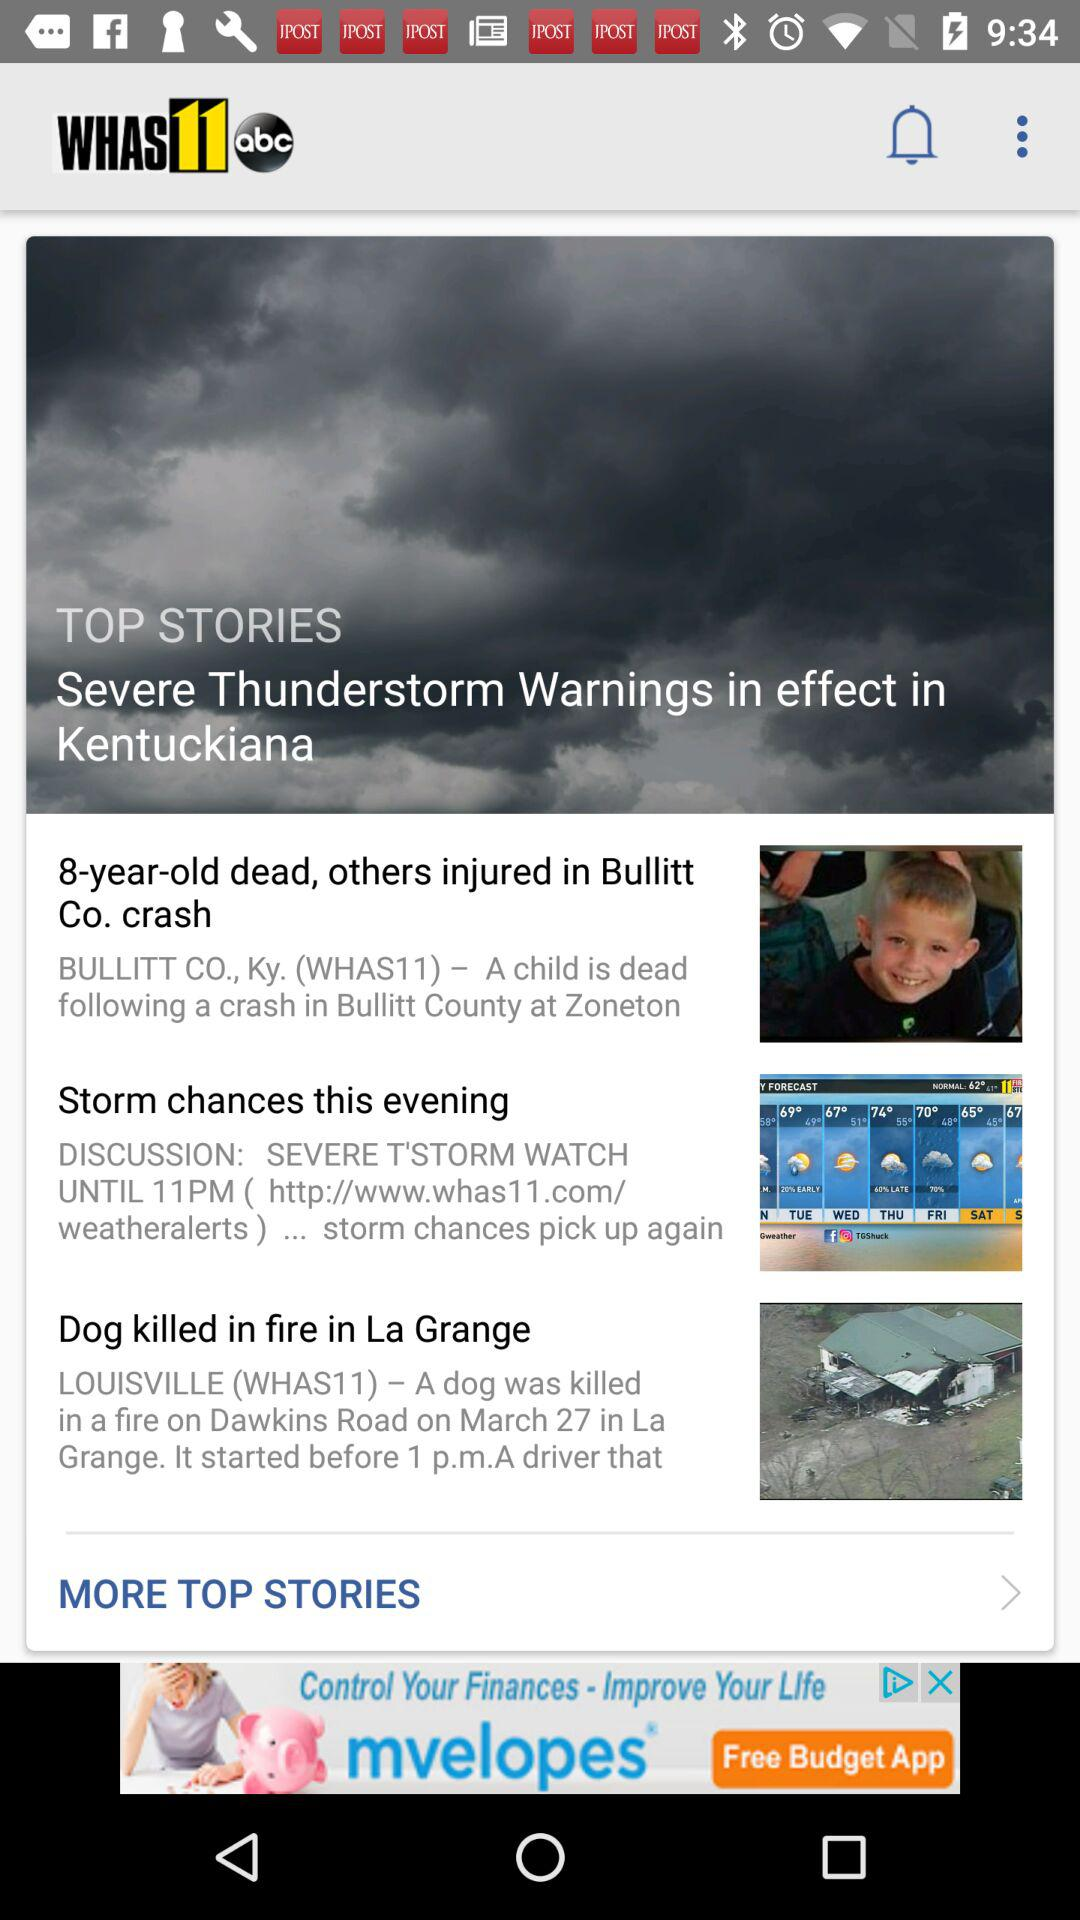How many stories are about weather?
Answer the question using a single word or phrase. 2 